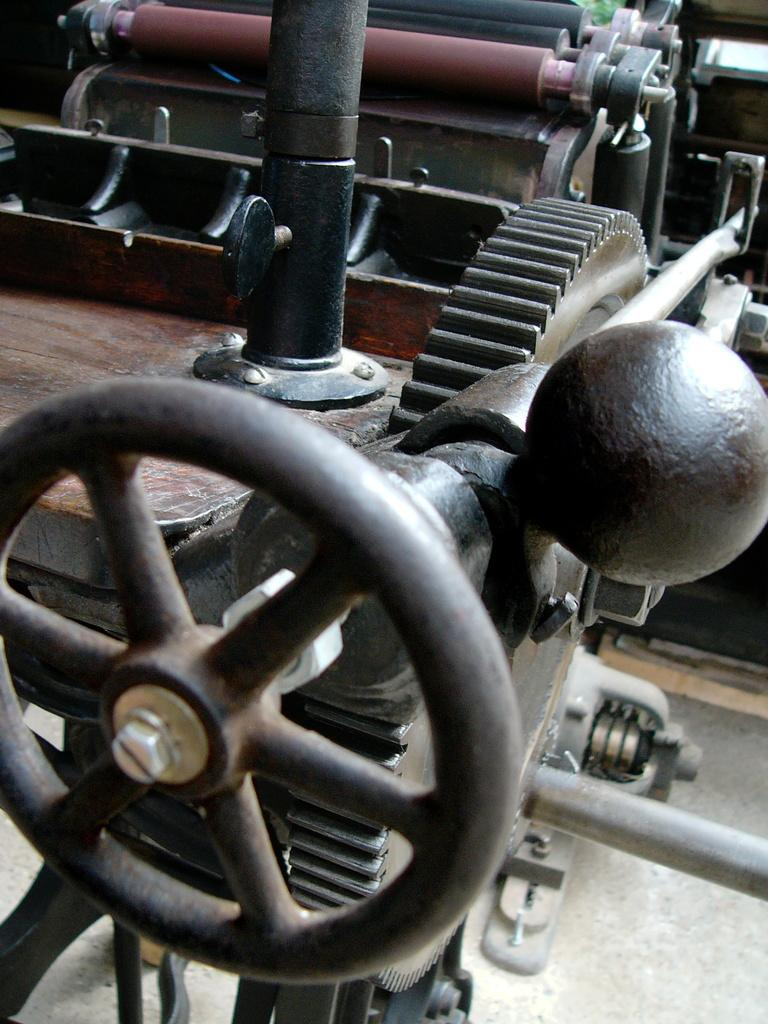What is the main subject in the image? There is a machine in the image. What type of quilt is being used to cover the machine in the image? There is no quilt present in the image; it only features a machine. How many tickets can be seen attached to the machine in the image? There are no tickets present in the image; it only features a machine. 